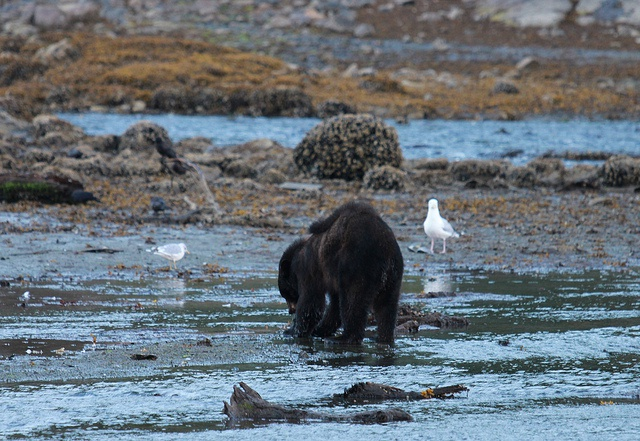Describe the objects in this image and their specific colors. I can see bear in gray, black, and blue tones, bird in gray, white, darkgray, and lightblue tones, bird in gray, lavender, lightblue, and darkgray tones, and bird in gray, black, and darkblue tones in this image. 